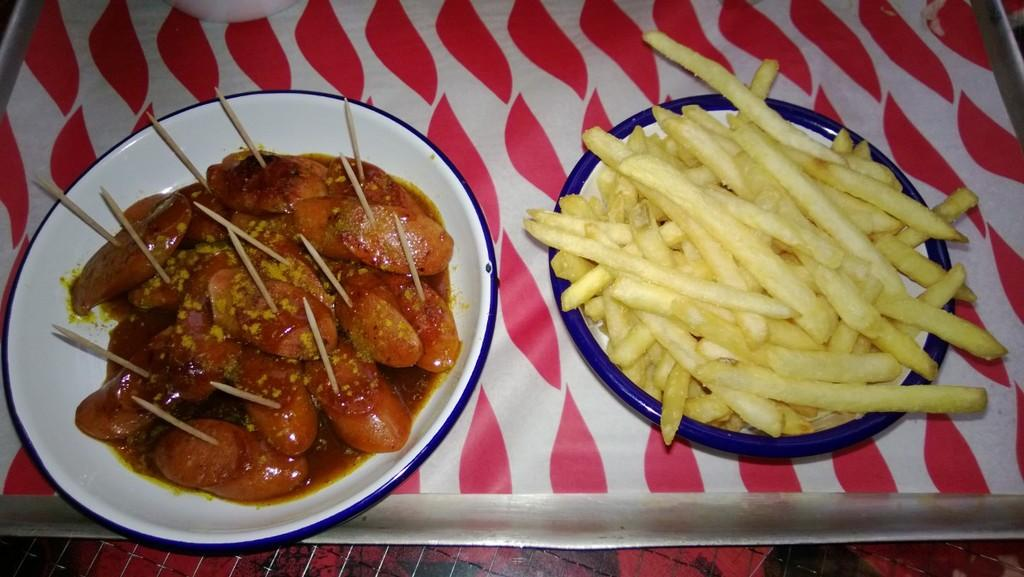What type of food can be seen in the image? There are french fries in the image. Are there any other food items visible besides the french fries? Yes, there are other food items in the image. What can be used to pick up or spear food in the image? Toothpicks are present in the image. What are the plates placed on in the image? The plates are on a platform. What type of development is taking place in the image? There is no development project or construction site visible in the image; it features food items and related objects. 